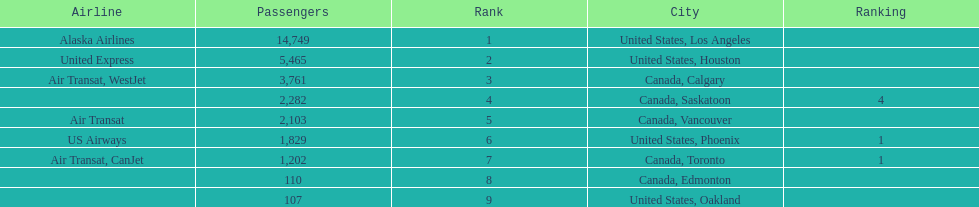Los angeles and what other city had about 19,000 passenger combined Canada, Calgary. 